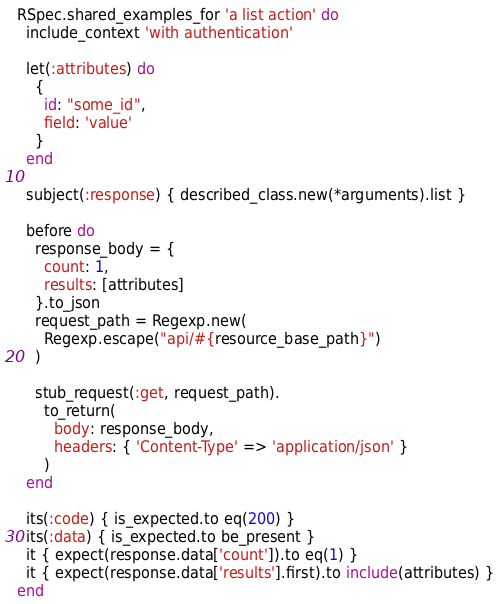<code> <loc_0><loc_0><loc_500><loc_500><_Ruby_>RSpec.shared_examples_for 'a list action' do
  include_context 'with authentication'

  let(:attributes) do
    {
      id: "some_id",
      field: 'value'
    }
  end

  subject(:response) { described_class.new(*arguments).list }

  before do
    response_body = {
      count: 1,
      results: [attributes]
    }.to_json
    request_path = Regexp.new(
      Regexp.escape("api/#{resource_base_path}")
    )

    stub_request(:get, request_path).
      to_return(
        body: response_body,
        headers: { 'Content-Type' => 'application/json' }
      )
  end

  its(:code) { is_expected.to eq(200) }
  its(:data) { is_expected.to be_present }
  it { expect(response.data['count']).to eq(1) }
  it { expect(response.data['results'].first).to include(attributes) }
end
</code> 